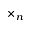Convert formula to latex. <formula><loc_0><loc_0><loc_500><loc_500>\times _ { n }</formula> 